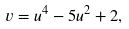<formula> <loc_0><loc_0><loc_500><loc_500>v = u ^ { 4 } - 5 u ^ { 2 } + 2 ,</formula> 